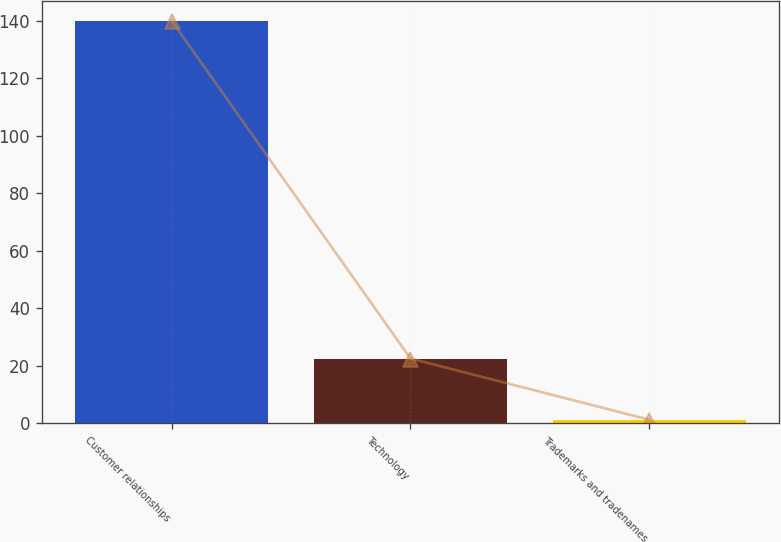Convert chart to OTSL. <chart><loc_0><loc_0><loc_500><loc_500><bar_chart><fcel>Customer relationships<fcel>Technology<fcel>Trademarks and tradenames<nl><fcel>140<fcel>22.5<fcel>1.2<nl></chart> 